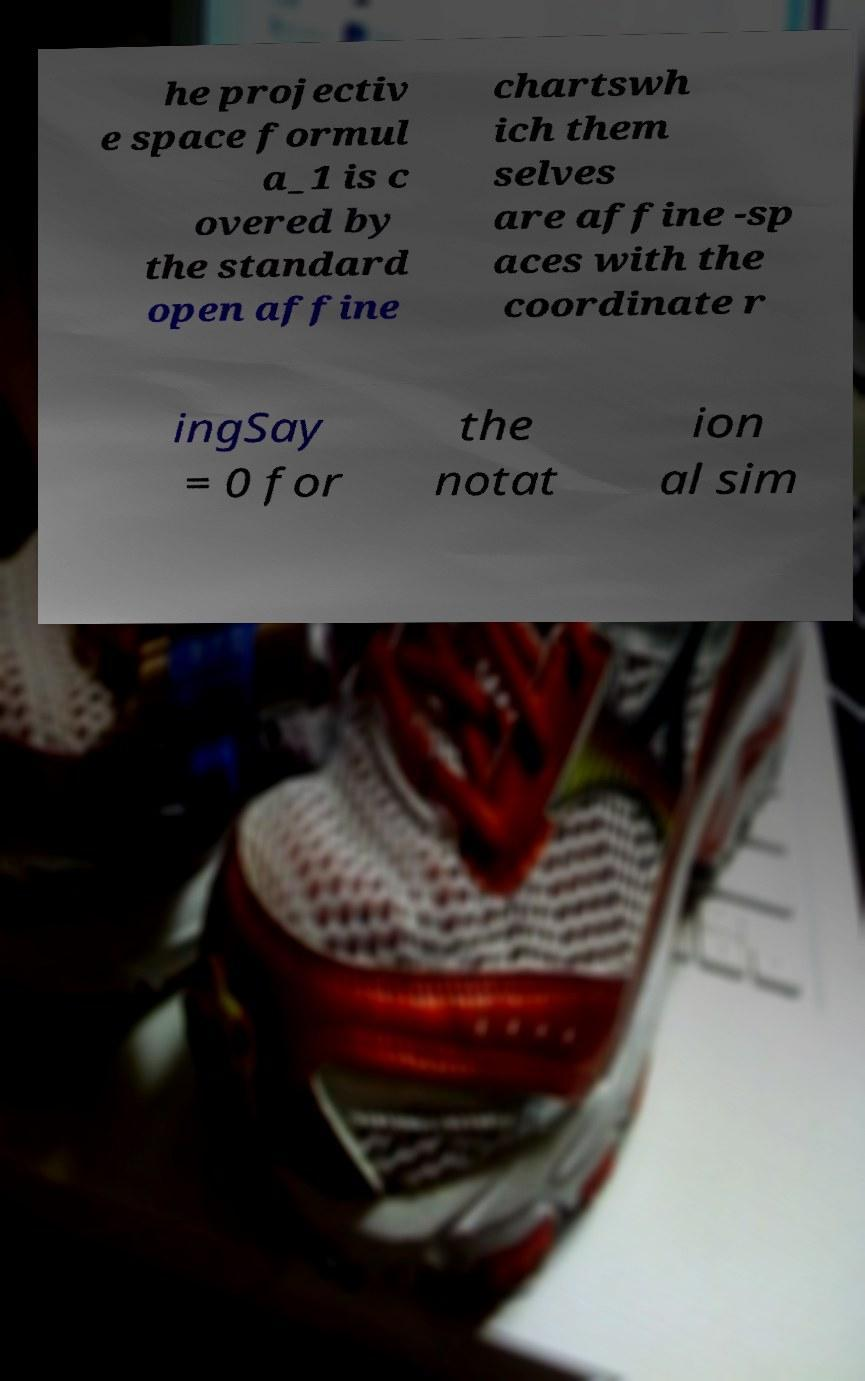I need the written content from this picture converted into text. Can you do that? he projectiv e space formul a_1 is c overed by the standard open affine chartswh ich them selves are affine -sp aces with the coordinate r ingSay = 0 for the notat ion al sim 